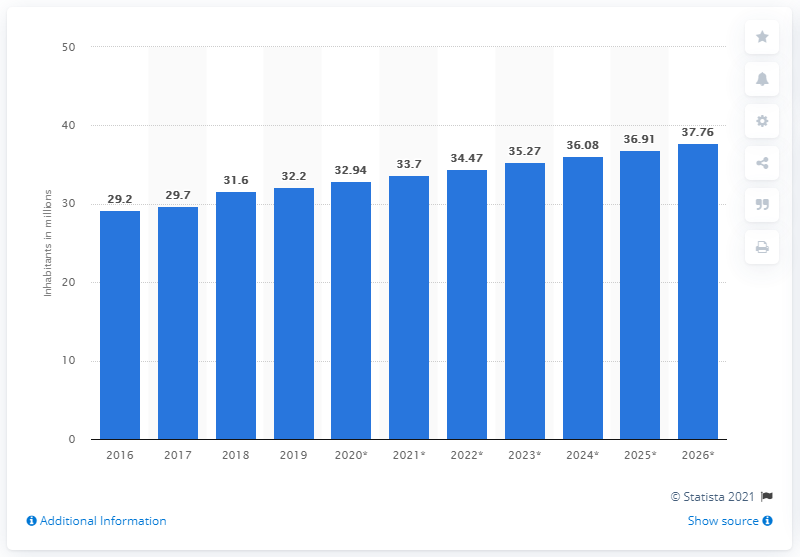Highlight a few significant elements in this photo. In 2019, the population of Afghanistan was approximately 32.2 million. 